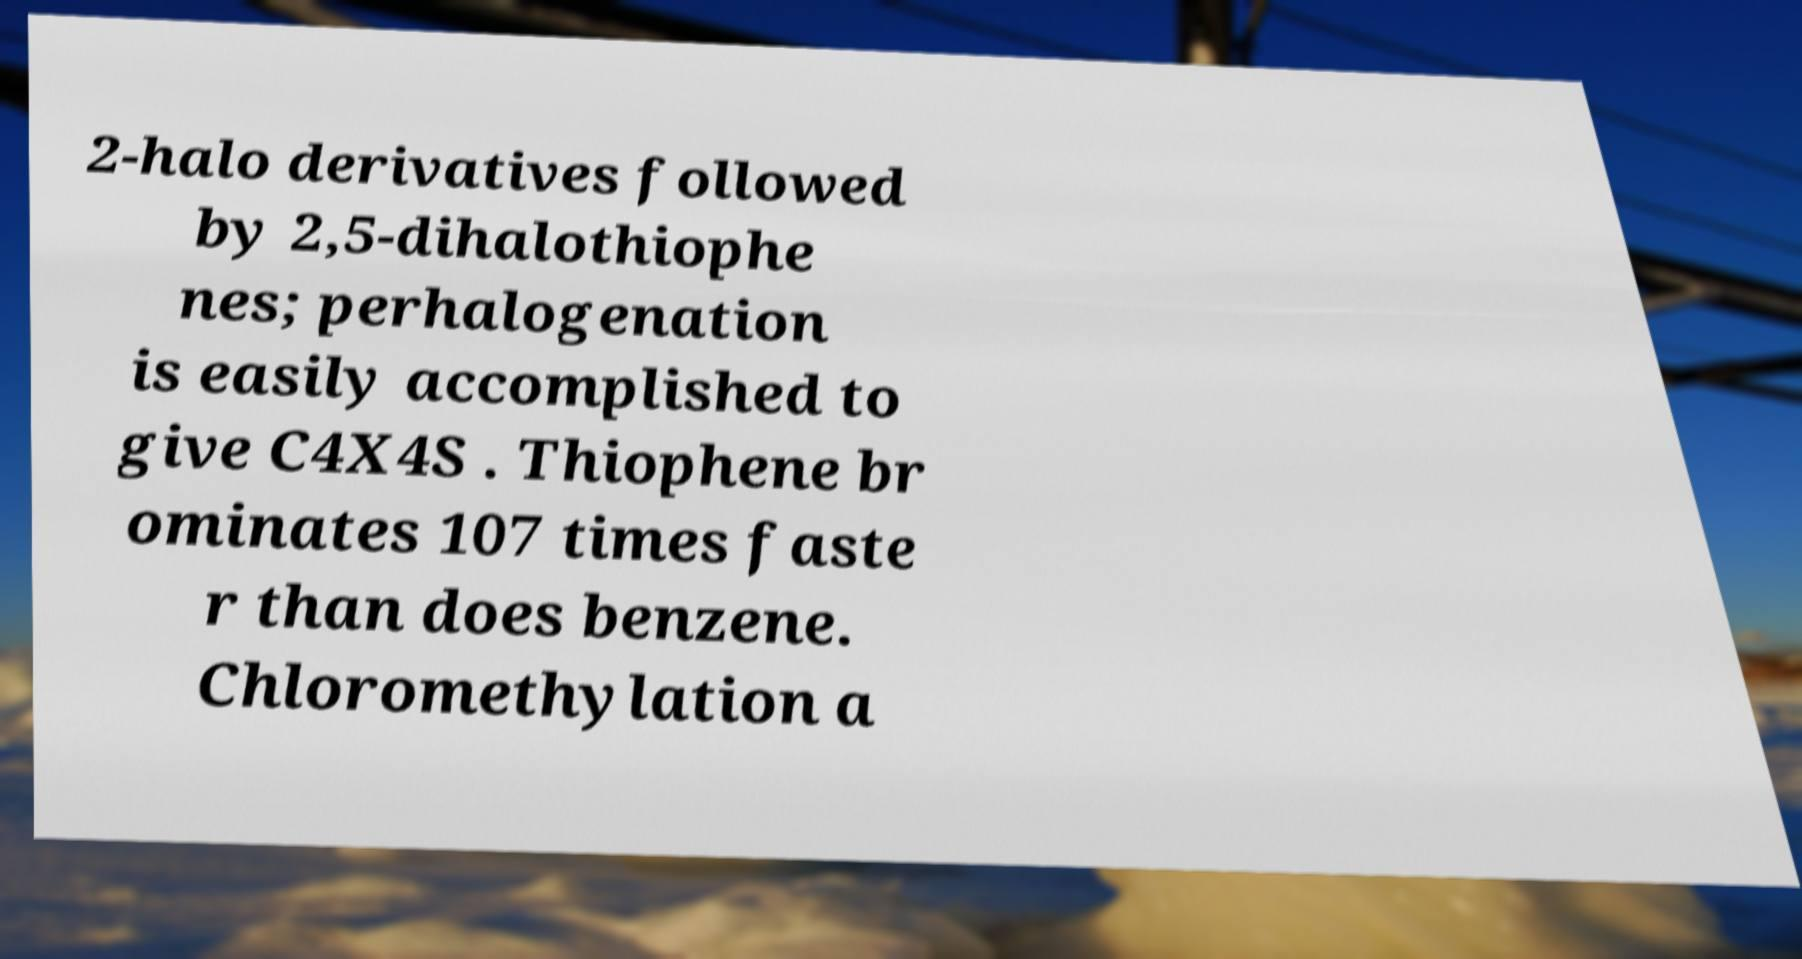Please identify and transcribe the text found in this image. 2-halo derivatives followed by 2,5-dihalothiophe nes; perhalogenation is easily accomplished to give C4X4S . Thiophene br ominates 107 times faste r than does benzene. Chloromethylation a 